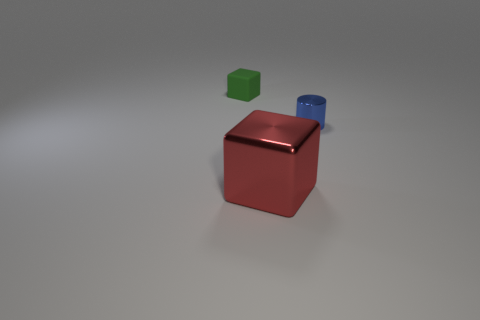Add 2 tiny cylinders. How many objects exist? 5 Subtract all blocks. How many objects are left? 1 Subtract 0 purple cylinders. How many objects are left? 3 Subtract all red metallic cylinders. Subtract all big red metallic objects. How many objects are left? 2 Add 3 cylinders. How many cylinders are left? 4 Add 3 small blue cylinders. How many small blue cylinders exist? 4 